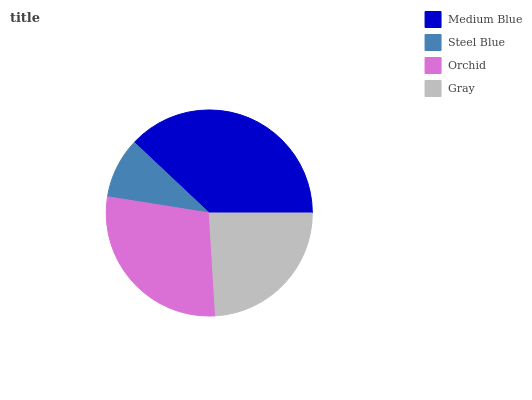Is Steel Blue the minimum?
Answer yes or no. Yes. Is Medium Blue the maximum?
Answer yes or no. Yes. Is Orchid the minimum?
Answer yes or no. No. Is Orchid the maximum?
Answer yes or no. No. Is Orchid greater than Steel Blue?
Answer yes or no. Yes. Is Steel Blue less than Orchid?
Answer yes or no. Yes. Is Steel Blue greater than Orchid?
Answer yes or no. No. Is Orchid less than Steel Blue?
Answer yes or no. No. Is Orchid the high median?
Answer yes or no. Yes. Is Gray the low median?
Answer yes or no. Yes. Is Medium Blue the high median?
Answer yes or no. No. Is Orchid the low median?
Answer yes or no. No. 